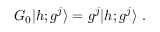<formula> <loc_0><loc_0><loc_500><loc_500>G _ { 0 } | h ; g ^ { j } \rangle = g ^ { j } | h ; g ^ { j } .</formula> 